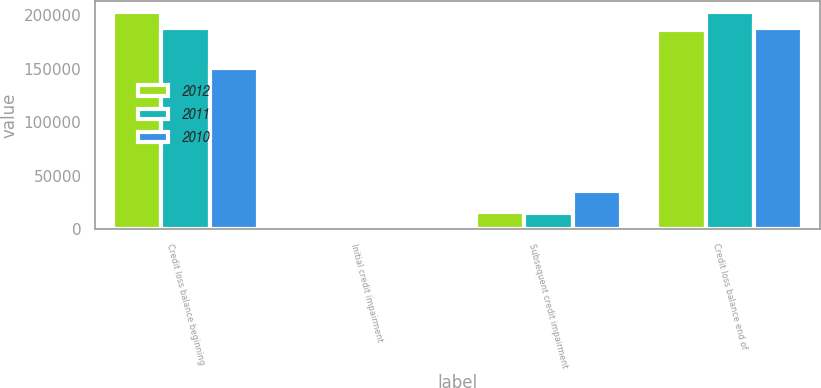Convert chart to OTSL. <chart><loc_0><loc_0><loc_500><loc_500><stacked_bar_chart><ecel><fcel>Credit loss balance beginning<fcel>Initial credit impairment<fcel>Subsequent credit impairment<fcel>Credit loss balance end of<nl><fcel>2012<fcel>202945<fcel>987<fcel>15938<fcel>186722<nl><fcel>2011<fcel>188038<fcel>61<fcel>14846<fcel>202945<nl><fcel>2010<fcel>150372<fcel>1642<fcel>36024<fcel>188038<nl></chart> 